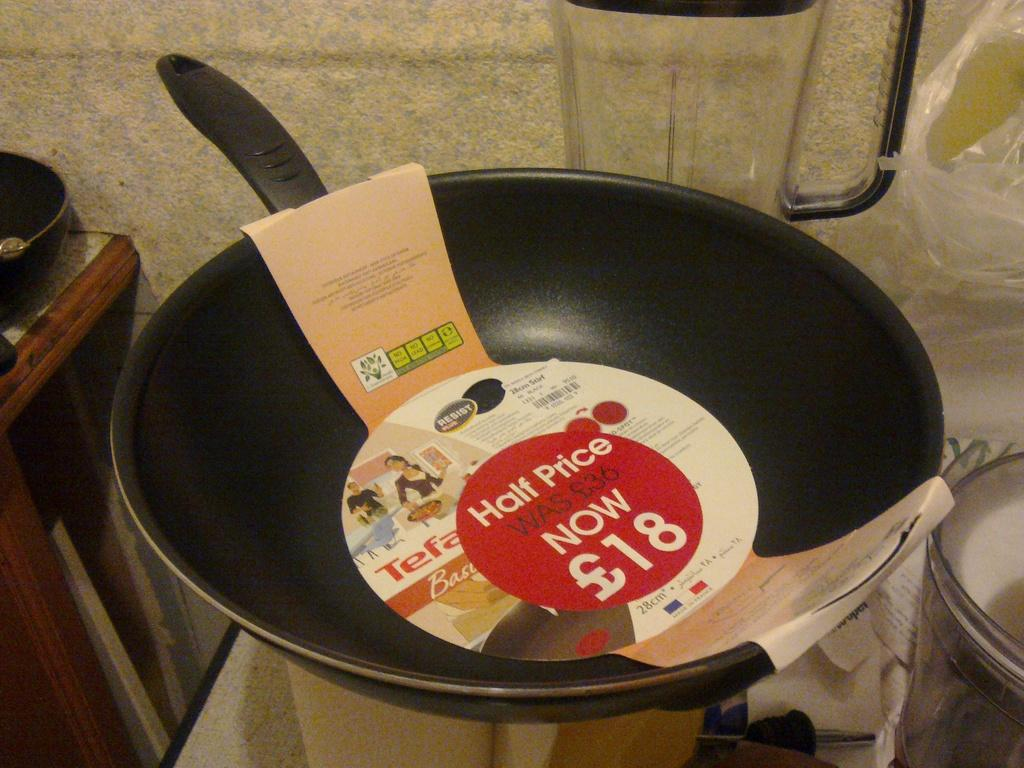<image>
Create a compact narrative representing the image presented. A wok with a sticker on the label that says half price. 